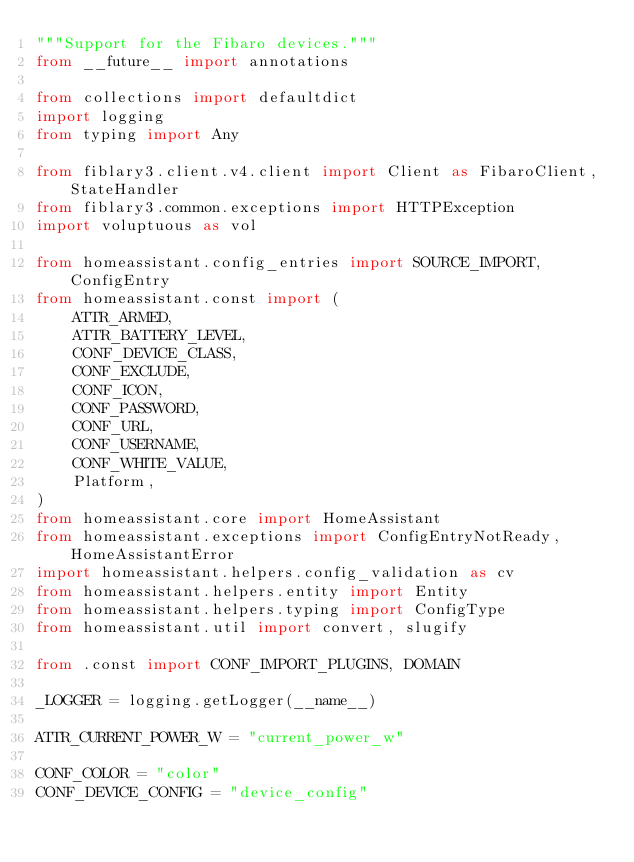Convert code to text. <code><loc_0><loc_0><loc_500><loc_500><_Python_>"""Support for the Fibaro devices."""
from __future__ import annotations

from collections import defaultdict
import logging
from typing import Any

from fiblary3.client.v4.client import Client as FibaroClient, StateHandler
from fiblary3.common.exceptions import HTTPException
import voluptuous as vol

from homeassistant.config_entries import SOURCE_IMPORT, ConfigEntry
from homeassistant.const import (
    ATTR_ARMED,
    ATTR_BATTERY_LEVEL,
    CONF_DEVICE_CLASS,
    CONF_EXCLUDE,
    CONF_ICON,
    CONF_PASSWORD,
    CONF_URL,
    CONF_USERNAME,
    CONF_WHITE_VALUE,
    Platform,
)
from homeassistant.core import HomeAssistant
from homeassistant.exceptions import ConfigEntryNotReady, HomeAssistantError
import homeassistant.helpers.config_validation as cv
from homeassistant.helpers.entity import Entity
from homeassistant.helpers.typing import ConfigType
from homeassistant.util import convert, slugify

from .const import CONF_IMPORT_PLUGINS, DOMAIN

_LOGGER = logging.getLogger(__name__)

ATTR_CURRENT_POWER_W = "current_power_w"

CONF_COLOR = "color"
CONF_DEVICE_CONFIG = "device_config"</code> 